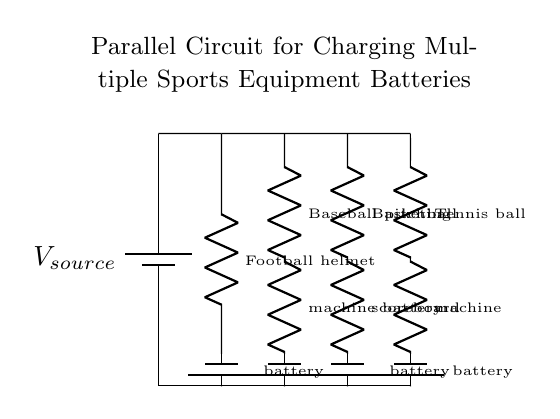What components are connected in this parallel circuit? The components consist of a power source and four different battery branches for sports equipment. Each branch includes a resistor and a battery.
Answer: power source, four batteries What is the label for the first branch in the circuit? The first branch is labeled as the "Football helmet," which indicates the type of battery being charged in that specific branch.
Answer: Football helmet How many branches are there in the circuit? By counting the lines representing branches, there are a total of four distinct branches connected to the main power source in this parallel circuit.
Answer: four What type of circuit is depicted in the diagram? The circuit is a parallel circuit, as indicated by the layout where multiple components are connected side-by-side to the same voltage source, allowing them to operate independently.
Answer: parallel Which sports equipment battery is located in the second branch? The second branch is labeled as "Baseball pitching," which pertains to the type of equipment being powered by that specific branch of the circuit.
Answer: Baseball pitching What characteristic is unique to parallel circuits regarding voltage? In a parallel circuit, the voltage across all branches remains the same as that of the voltage source, which is a key feature distinguishing it from series circuits.
Answer: same voltage Which battery is associated with tennis equipment? The branch related to tennis equipment is labeled with "Tennis ball machine," indicating the specific type of battery being utilized in that branch.
Answer: Tennis ball machine 